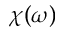<formula> <loc_0><loc_0><loc_500><loc_500>\chi ( \omega )</formula> 